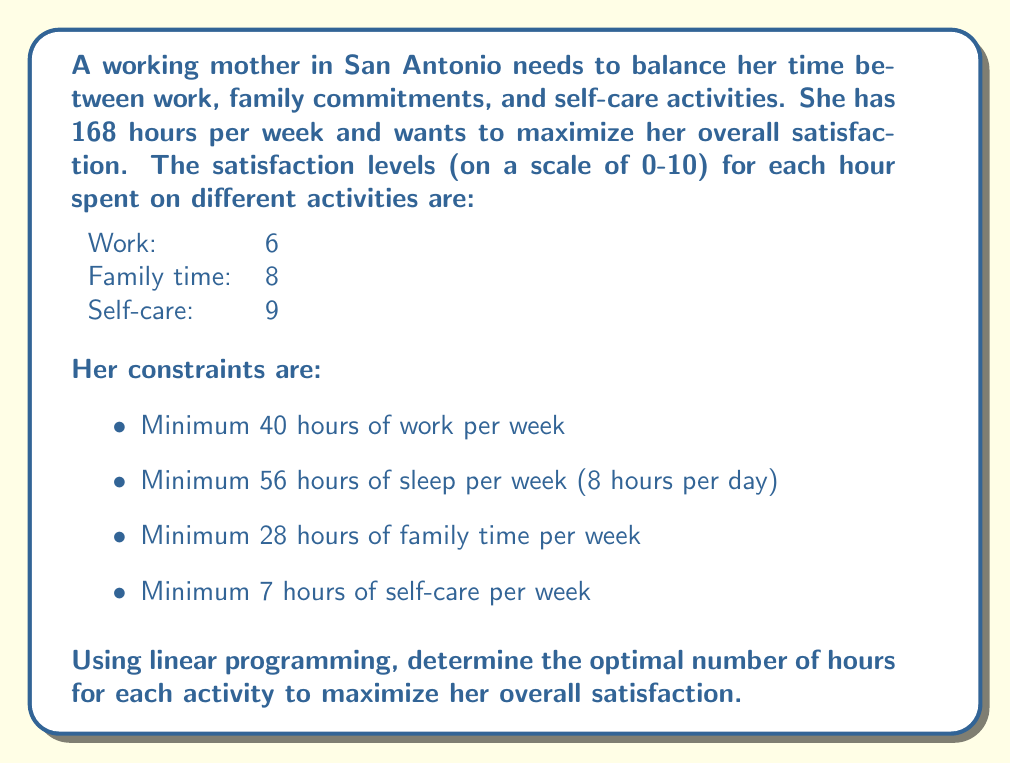Give your solution to this math problem. Let's solve this problem using linear programming:

1. Define variables:
   $x_1$ = hours spent on work
   $x_2$ = hours spent on family time
   $x_3$ = hours spent on self-care
   $x_4$ = hours spent on sleep

2. Objective function (maximize satisfaction):
   $$ \text{Maximize } Z = 6x_1 + 8x_2 + 9x_3 $$

3. Constraints:
   $$ x_1 + x_2 + x_3 + x_4 = 168 \text{ (total hours)} $$
   $$ x_1 \geq 40 \text{ (minimum work hours)} $$
   $$ x_2 \geq 28 \text{ (minimum family time)} $$
   $$ x_3 \geq 7 \text{ (minimum self-care)} $$
   $$ x_4 = 56 \text{ (fixed sleep hours)} $$
   $$ x_1, x_2, x_3, x_4 \geq 0 \text{ (non-negativity)} $$

4. Simplify by substituting $x_4 = 56$:
   $$ x_1 + x_2 + x_3 = 112 $$

5. Set up the linear programming tableau:
   $$
   \begin{array}{c|ccc|c}
      & x_1 & x_2 & x_3 & \text{RHS} \\
   \hline
   Z & -6 & -8 & -9 & 0 \\
   x_1 & 1 & 0 & 0 & 40 \\
   x_2 & 0 & 1 & 0 & 28 \\
   x_3 & 0 & 0 & 1 & 7 \\
   \text{Total} & 1 & 1 & 1 & 112 \\
   \end{array}
   $$

6. Solve using the simplex method:
   The optimal solution is reached when we allocate the remaining hours to the activity with the highest satisfaction rate (self-care).

7. Final allocation:
   Work: 40 hours (minimum required)
   Family time: 28 hours (minimum required)
   Self-care: 44 hours (112 - 40 - 28)
   Sleep: 56 hours (fixed)

8. Calculate maximum satisfaction:
   $$ Z = 6(40) + 8(28) + 9(44) = 240 + 224 + 396 = 860 $$
Answer: Work: 40 hours, Family: 28 hours, Self-care: 44 hours, Sleep: 56 hours. Maximum satisfaction: 860. 